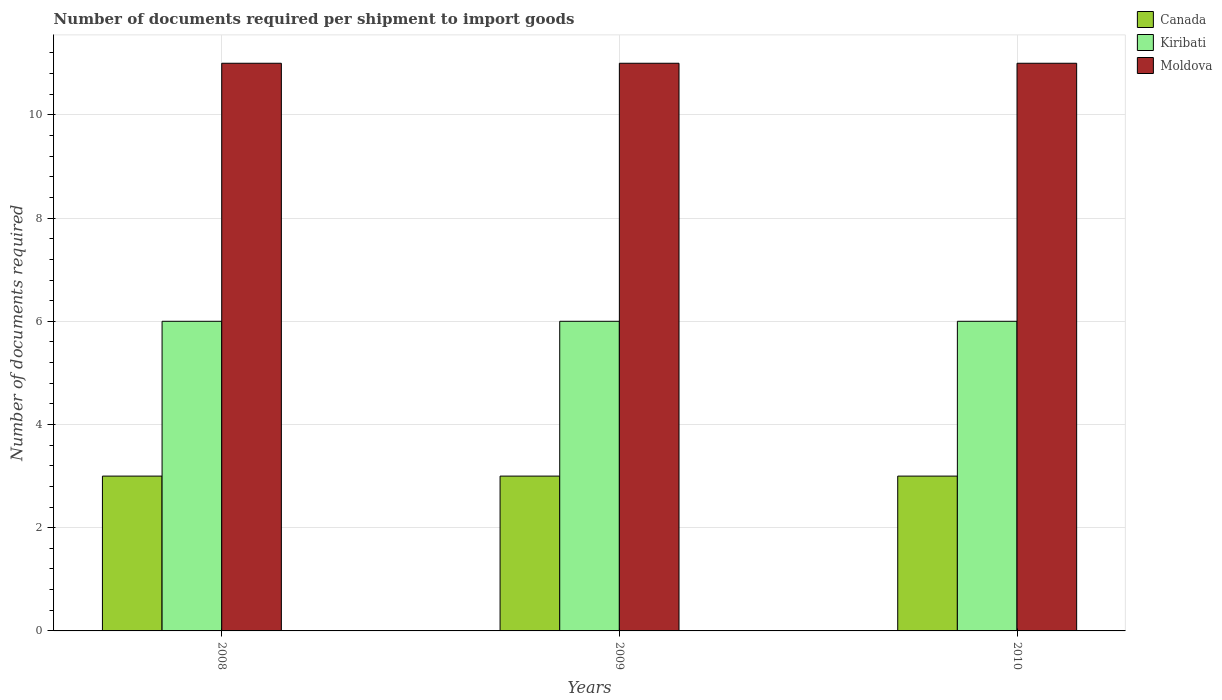How many bars are there on the 3rd tick from the left?
Ensure brevity in your answer.  3. What is the number of documents required per shipment to import goods in Canada in 2008?
Your answer should be compact. 3. Across all years, what is the maximum number of documents required per shipment to import goods in Kiribati?
Provide a succinct answer. 6. Across all years, what is the minimum number of documents required per shipment to import goods in Canada?
Provide a succinct answer. 3. In which year was the number of documents required per shipment to import goods in Canada maximum?
Offer a very short reply. 2008. What is the total number of documents required per shipment to import goods in Canada in the graph?
Provide a succinct answer. 9. What is the difference between the number of documents required per shipment to import goods in Kiribati in 2010 and the number of documents required per shipment to import goods in Moldova in 2009?
Keep it short and to the point. -5. What is the average number of documents required per shipment to import goods in Kiribati per year?
Provide a short and direct response. 6. In the year 2008, what is the difference between the number of documents required per shipment to import goods in Canada and number of documents required per shipment to import goods in Kiribati?
Give a very brief answer. -3. What is the ratio of the number of documents required per shipment to import goods in Canada in 2009 to that in 2010?
Offer a very short reply. 1. Is the difference between the number of documents required per shipment to import goods in Canada in 2008 and 2009 greater than the difference between the number of documents required per shipment to import goods in Kiribati in 2008 and 2009?
Give a very brief answer. No. What is the difference between the highest and the second highest number of documents required per shipment to import goods in Moldova?
Your response must be concise. 0. What does the 2nd bar from the left in 2009 represents?
Give a very brief answer. Kiribati. What does the 3rd bar from the right in 2008 represents?
Offer a very short reply. Canada. How many bars are there?
Give a very brief answer. 9. Are all the bars in the graph horizontal?
Provide a short and direct response. No. How many years are there in the graph?
Offer a terse response. 3. Are the values on the major ticks of Y-axis written in scientific E-notation?
Your answer should be compact. No. Does the graph contain any zero values?
Your answer should be very brief. No. Where does the legend appear in the graph?
Make the answer very short. Top right. How are the legend labels stacked?
Offer a terse response. Vertical. What is the title of the graph?
Ensure brevity in your answer.  Number of documents required per shipment to import goods. Does "Eritrea" appear as one of the legend labels in the graph?
Offer a terse response. No. What is the label or title of the X-axis?
Your response must be concise. Years. What is the label or title of the Y-axis?
Ensure brevity in your answer.  Number of documents required. What is the Number of documents required in Canada in 2009?
Your answer should be very brief. 3. What is the Number of documents required in Kiribati in 2010?
Your answer should be very brief. 6. What is the Number of documents required in Moldova in 2010?
Offer a very short reply. 11. Across all years, what is the maximum Number of documents required in Canada?
Give a very brief answer. 3. Across all years, what is the maximum Number of documents required in Kiribati?
Provide a short and direct response. 6. Across all years, what is the minimum Number of documents required in Canada?
Ensure brevity in your answer.  3. Across all years, what is the minimum Number of documents required of Moldova?
Offer a terse response. 11. What is the difference between the Number of documents required of Canada in 2008 and that in 2009?
Provide a succinct answer. 0. What is the difference between the Number of documents required in Canada in 2008 and that in 2010?
Ensure brevity in your answer.  0. What is the difference between the Number of documents required of Kiribati in 2008 and that in 2010?
Your answer should be compact. 0. What is the difference between the Number of documents required in Moldova in 2008 and that in 2010?
Your response must be concise. 0. What is the difference between the Number of documents required in Moldova in 2009 and that in 2010?
Your answer should be very brief. 0. What is the difference between the Number of documents required of Canada in 2008 and the Number of documents required of Kiribati in 2009?
Your answer should be very brief. -3. What is the difference between the Number of documents required of Kiribati in 2008 and the Number of documents required of Moldova in 2009?
Keep it short and to the point. -5. What is the difference between the Number of documents required in Kiribati in 2008 and the Number of documents required in Moldova in 2010?
Offer a very short reply. -5. What is the difference between the Number of documents required of Kiribati in 2009 and the Number of documents required of Moldova in 2010?
Your response must be concise. -5. In the year 2008, what is the difference between the Number of documents required of Canada and Number of documents required of Kiribati?
Ensure brevity in your answer.  -3. In the year 2008, what is the difference between the Number of documents required of Canada and Number of documents required of Moldova?
Your response must be concise. -8. In the year 2008, what is the difference between the Number of documents required of Kiribati and Number of documents required of Moldova?
Your answer should be compact. -5. In the year 2009, what is the difference between the Number of documents required of Canada and Number of documents required of Kiribati?
Make the answer very short. -3. In the year 2009, what is the difference between the Number of documents required in Canada and Number of documents required in Moldova?
Offer a very short reply. -8. In the year 2010, what is the difference between the Number of documents required in Canada and Number of documents required in Moldova?
Offer a very short reply. -8. In the year 2010, what is the difference between the Number of documents required in Kiribati and Number of documents required in Moldova?
Provide a short and direct response. -5. What is the ratio of the Number of documents required of Canada in 2008 to that in 2009?
Your response must be concise. 1. What is the ratio of the Number of documents required of Kiribati in 2008 to that in 2009?
Your answer should be compact. 1. What is the ratio of the Number of documents required of Kiribati in 2008 to that in 2010?
Keep it short and to the point. 1. What is the ratio of the Number of documents required in Moldova in 2008 to that in 2010?
Offer a terse response. 1. What is the ratio of the Number of documents required of Moldova in 2009 to that in 2010?
Provide a short and direct response. 1. What is the difference between the highest and the second highest Number of documents required of Canada?
Your answer should be very brief. 0. What is the difference between the highest and the second highest Number of documents required in Kiribati?
Your answer should be compact. 0. What is the difference between the highest and the lowest Number of documents required in Kiribati?
Offer a terse response. 0. 